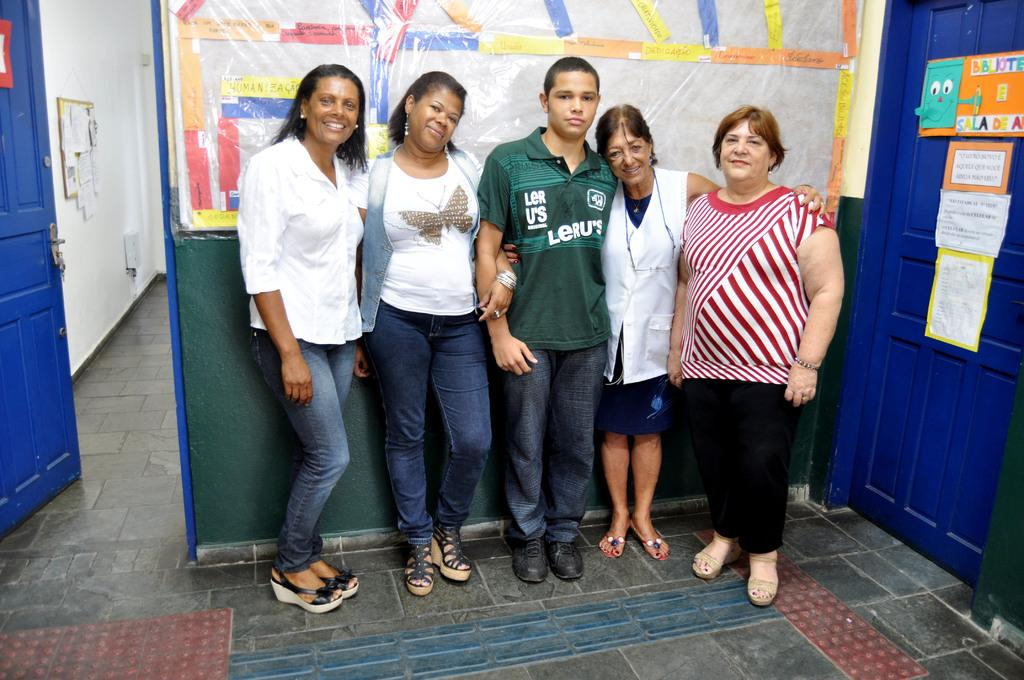How many people are in the foreground of the image? There are four women and a man in the foreground of the image. What are the people in the foreground doing? They are standing on the floor. What can be seen in the background of the image? In the background, there are two blue doors, a wall, posters on the wall, a board, and the floor. What type of stone is being used to hold the basket in the image? There is no basket or stone present in the image. How many jellyfish are swimming in the background of the image? There are no jellyfish present in the image. 